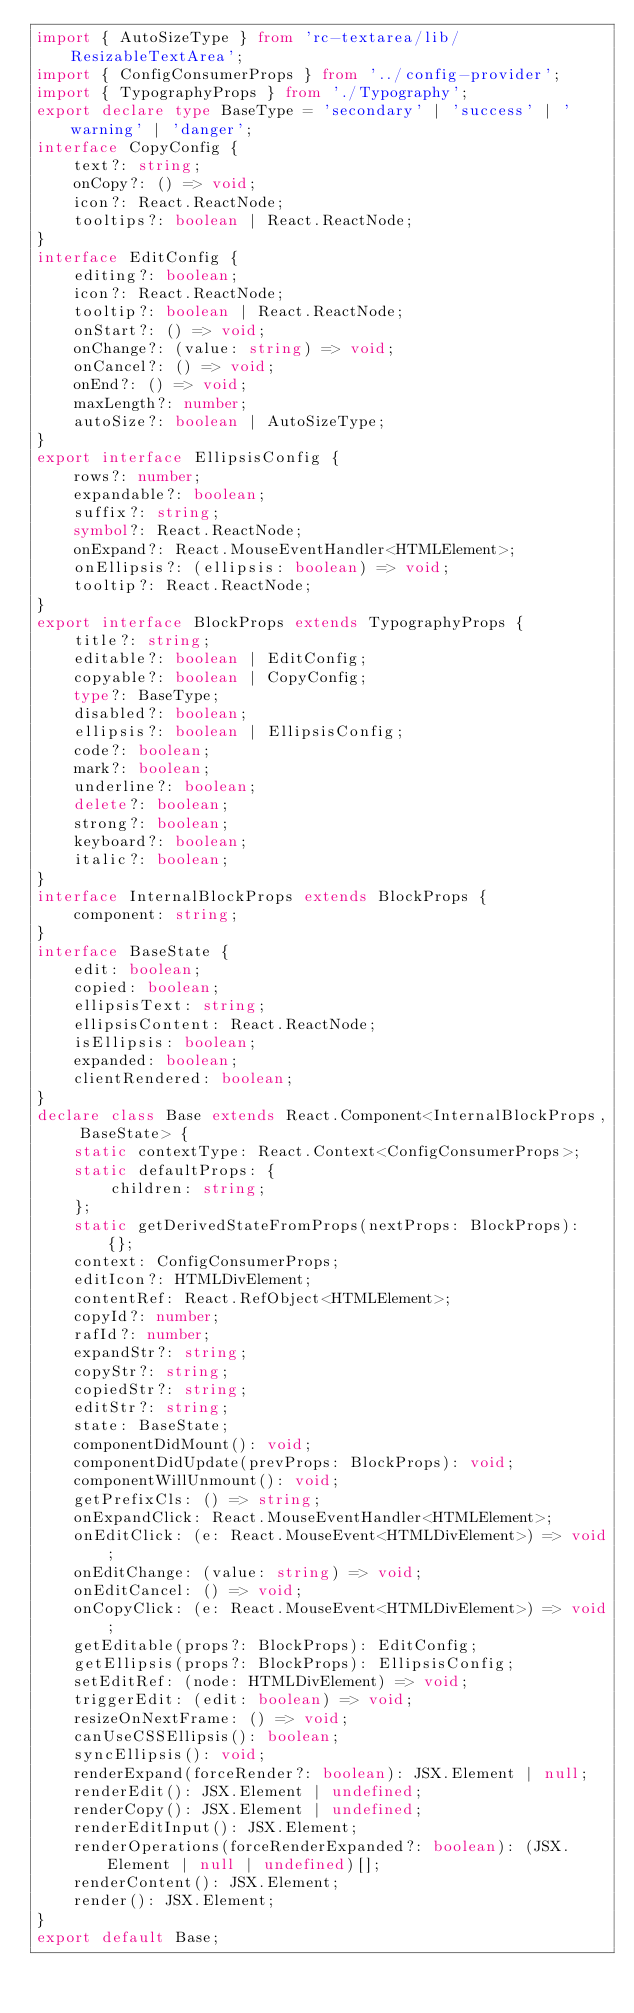Convert code to text. <code><loc_0><loc_0><loc_500><loc_500><_TypeScript_>import { AutoSizeType } from 'rc-textarea/lib/ResizableTextArea';
import { ConfigConsumerProps } from '../config-provider';
import { TypographyProps } from './Typography';
export declare type BaseType = 'secondary' | 'success' | 'warning' | 'danger';
interface CopyConfig {
    text?: string;
    onCopy?: () => void;
    icon?: React.ReactNode;
    tooltips?: boolean | React.ReactNode;
}
interface EditConfig {
    editing?: boolean;
    icon?: React.ReactNode;
    tooltip?: boolean | React.ReactNode;
    onStart?: () => void;
    onChange?: (value: string) => void;
    onCancel?: () => void;
    onEnd?: () => void;
    maxLength?: number;
    autoSize?: boolean | AutoSizeType;
}
export interface EllipsisConfig {
    rows?: number;
    expandable?: boolean;
    suffix?: string;
    symbol?: React.ReactNode;
    onExpand?: React.MouseEventHandler<HTMLElement>;
    onEllipsis?: (ellipsis: boolean) => void;
    tooltip?: React.ReactNode;
}
export interface BlockProps extends TypographyProps {
    title?: string;
    editable?: boolean | EditConfig;
    copyable?: boolean | CopyConfig;
    type?: BaseType;
    disabled?: boolean;
    ellipsis?: boolean | EllipsisConfig;
    code?: boolean;
    mark?: boolean;
    underline?: boolean;
    delete?: boolean;
    strong?: boolean;
    keyboard?: boolean;
    italic?: boolean;
}
interface InternalBlockProps extends BlockProps {
    component: string;
}
interface BaseState {
    edit: boolean;
    copied: boolean;
    ellipsisText: string;
    ellipsisContent: React.ReactNode;
    isEllipsis: boolean;
    expanded: boolean;
    clientRendered: boolean;
}
declare class Base extends React.Component<InternalBlockProps, BaseState> {
    static contextType: React.Context<ConfigConsumerProps>;
    static defaultProps: {
        children: string;
    };
    static getDerivedStateFromProps(nextProps: BlockProps): {};
    context: ConfigConsumerProps;
    editIcon?: HTMLDivElement;
    contentRef: React.RefObject<HTMLElement>;
    copyId?: number;
    rafId?: number;
    expandStr?: string;
    copyStr?: string;
    copiedStr?: string;
    editStr?: string;
    state: BaseState;
    componentDidMount(): void;
    componentDidUpdate(prevProps: BlockProps): void;
    componentWillUnmount(): void;
    getPrefixCls: () => string;
    onExpandClick: React.MouseEventHandler<HTMLElement>;
    onEditClick: (e: React.MouseEvent<HTMLDivElement>) => void;
    onEditChange: (value: string) => void;
    onEditCancel: () => void;
    onCopyClick: (e: React.MouseEvent<HTMLDivElement>) => void;
    getEditable(props?: BlockProps): EditConfig;
    getEllipsis(props?: BlockProps): EllipsisConfig;
    setEditRef: (node: HTMLDivElement) => void;
    triggerEdit: (edit: boolean) => void;
    resizeOnNextFrame: () => void;
    canUseCSSEllipsis(): boolean;
    syncEllipsis(): void;
    renderExpand(forceRender?: boolean): JSX.Element | null;
    renderEdit(): JSX.Element | undefined;
    renderCopy(): JSX.Element | undefined;
    renderEditInput(): JSX.Element;
    renderOperations(forceRenderExpanded?: boolean): (JSX.Element | null | undefined)[];
    renderContent(): JSX.Element;
    render(): JSX.Element;
}
export default Base;
</code> 